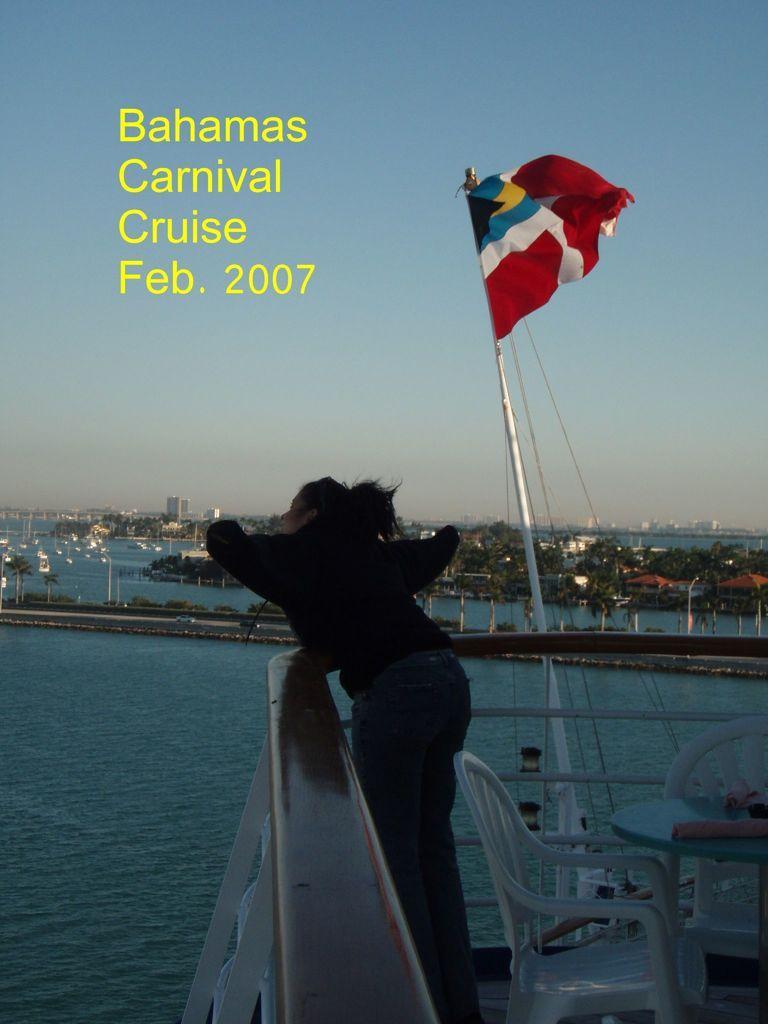Describe this image in one or two sentences. In this picture I can see the flag. I can see water. I can see trees. I can see sitting chairs and a table. I can see a person. I can see the buildings. I can see clouds in the sky. I can see the roads. 